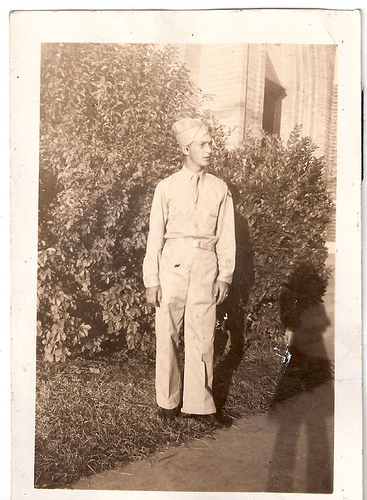<image>
Can you confirm if the uniform is under the person? No. The uniform is not positioned under the person. The vertical relationship between these objects is different. 